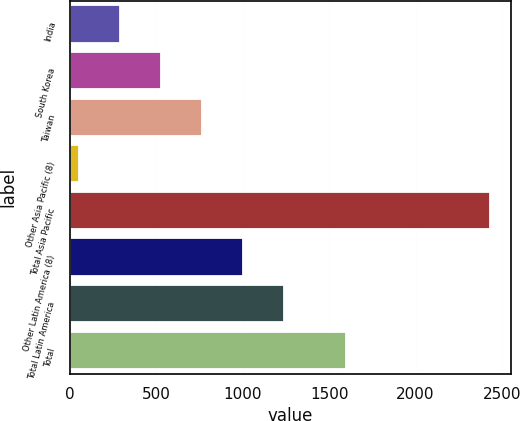<chart> <loc_0><loc_0><loc_500><loc_500><bar_chart><fcel>India<fcel>South Korea<fcel>Taiwan<fcel>Other Asia Pacific (8)<fcel>Total Asia Pacific<fcel>Other Latin America (8)<fcel>Total Latin America<fcel>Total<nl><fcel>287.1<fcel>525.2<fcel>763.3<fcel>49<fcel>2430<fcel>1001.4<fcel>1239.5<fcel>1599<nl></chart> 